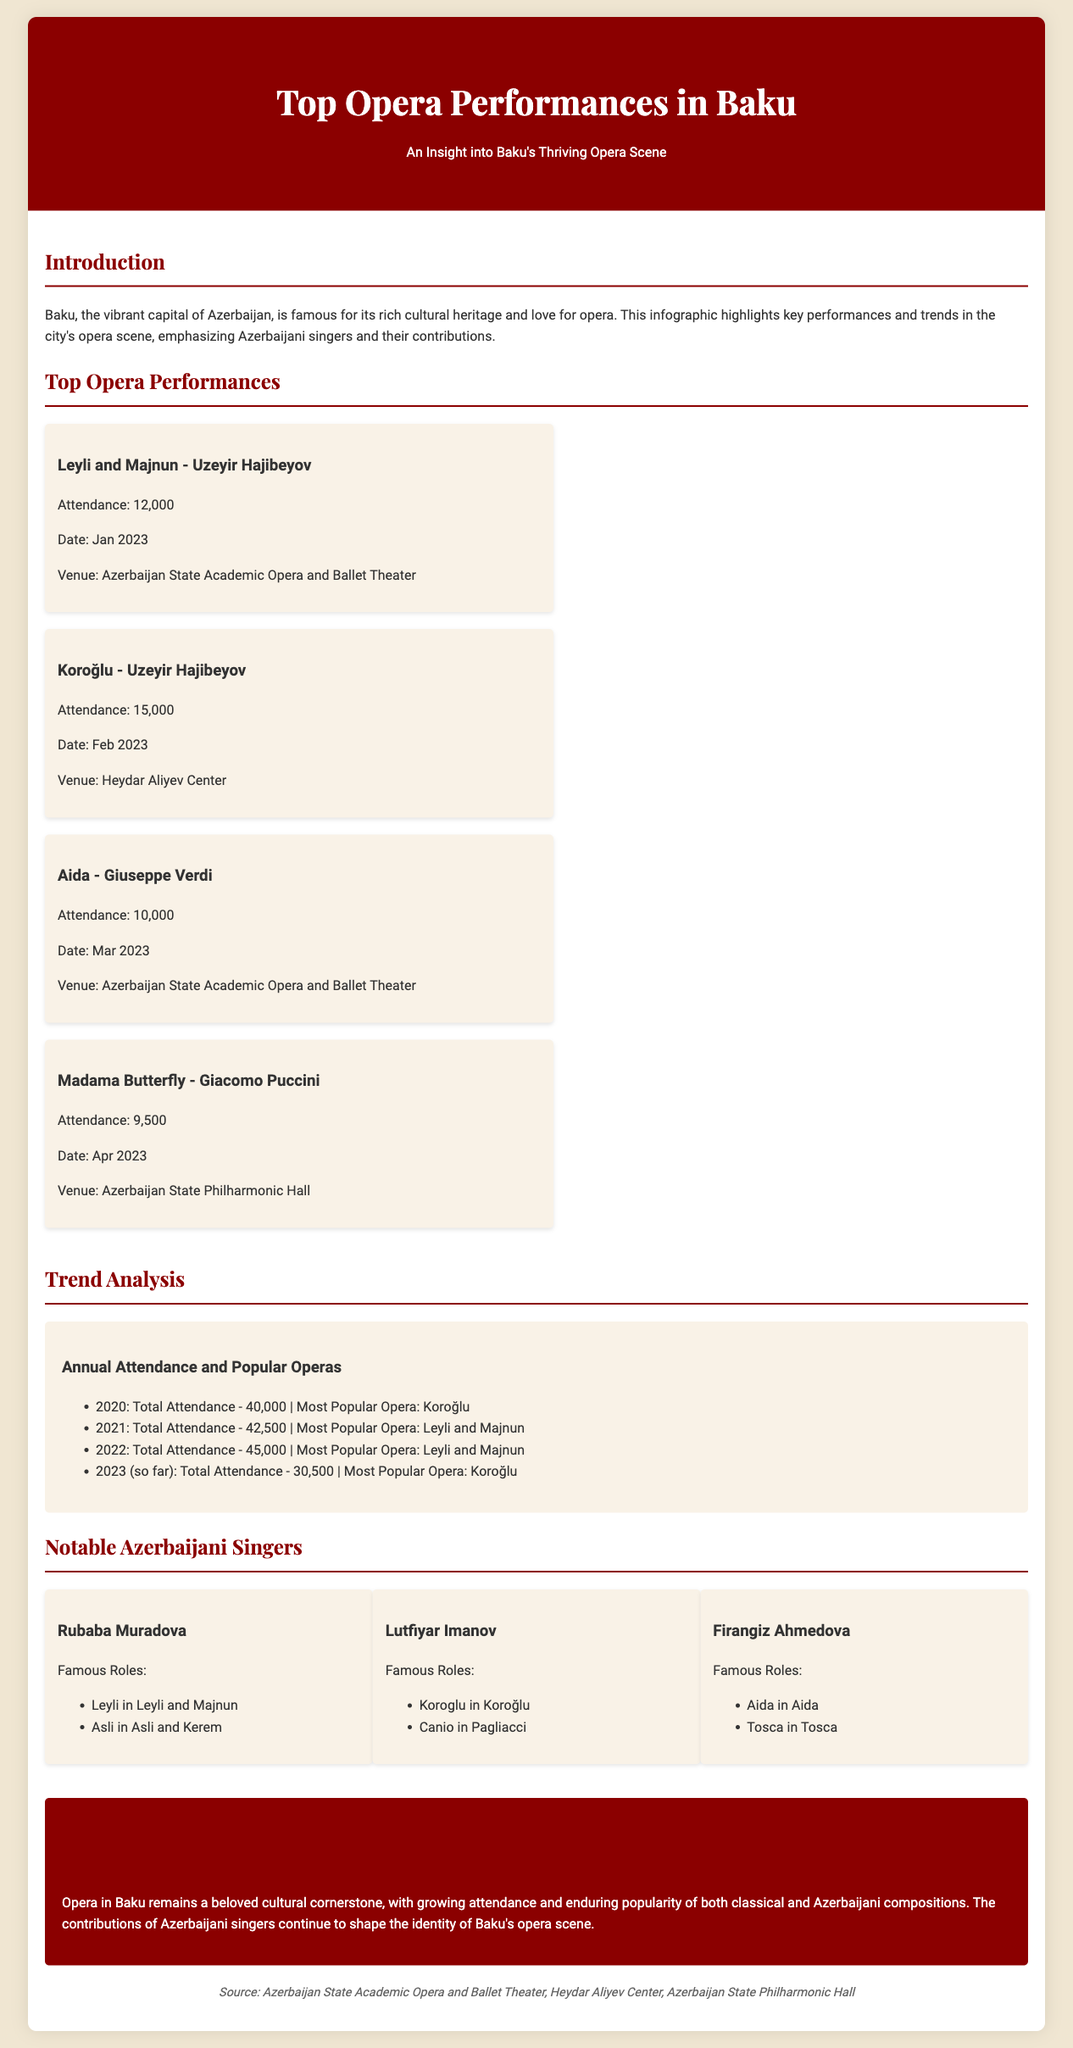What was the attendance for Koroğlu in February 2023? The attendance for Koroğlu in February 2023 is mentioned in the document as 15,000.
Answer: 15,000 Which opera had the highest attendance in 2022? The document states that Leyli and Majnun was the most popular opera in 2022, inferring it had the highest attendance relative to other operas for that year.
Answer: Leyli and Majnun When was Aida performed in Baku? The performance date for Aida is specified in the document as March 2023.
Answer: March 2023 Who played the role of Leyli in Leyli and Majnun? The document lists Rubaba Muradova as the singer who performed the role of Leyli.
Answer: Rubaba Muradova What has been the trend in annual attendance from 2020 to 2023 so far? The data in the document shows a steady increase in attendance until 2022, followed by a dip in 2023 with total attendance recorded at 30,500.
Answer: Decrease in 2023 What venue hosted Aida in March 2023? The venue for Aida in March 2023 is specified as the Azerbaijan State Academic Opera and Ballet Theater in the document.
Answer: Azerbaijan State Academic Opera and Ballet Theater What is the most popular opera of 2023 so far? Koroğlu is designated as the most popular opera of 2023 in the provided data.
Answer: Koroğlu How many notable Azerbaijani singers are listed? The document lists three notable Azerbaijani singers.
Answer: Three 